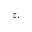Convert formula to latex. <formula><loc_0><loc_0><loc_500><loc_500>z ,</formula> 